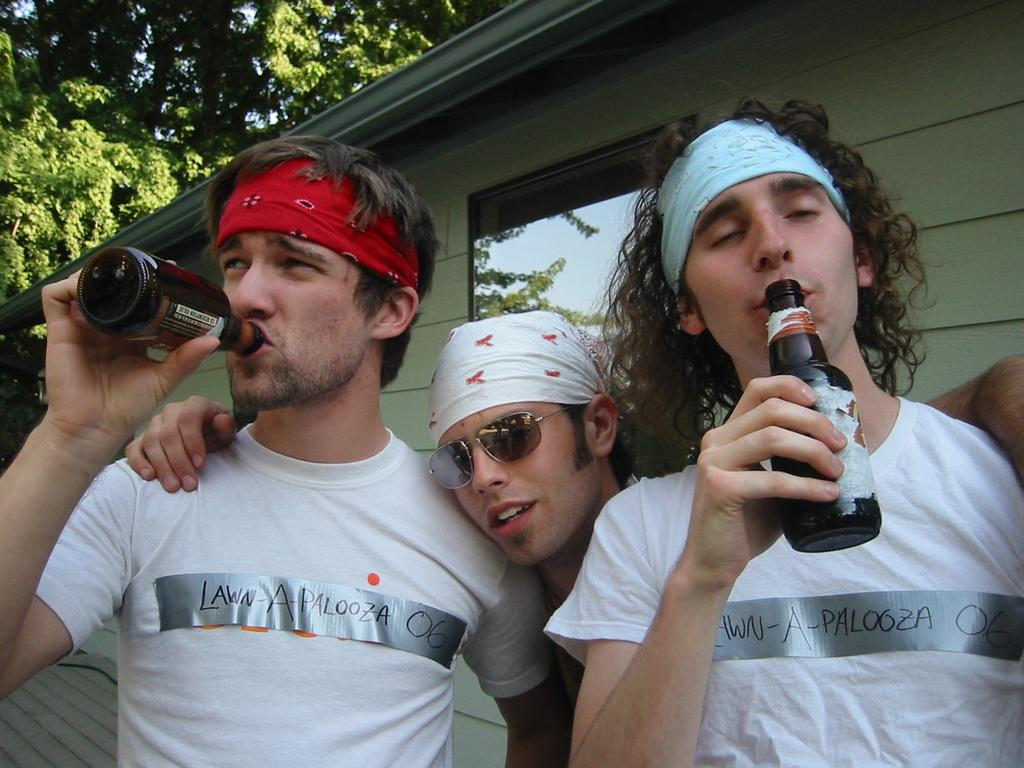Who or what is present in the image? There are people in the image. What are the people holding in their hands? The people are holding bottles. What can be seen in the distance behind the people? There is a house and a tree in the background of the image. What type of coal is being used to write in the notebook in the image? There is no coal or notebook present in the image. How does the sand affect the people's activities in the image? There is no sand present in the image, so it does not affect the people's activities. 